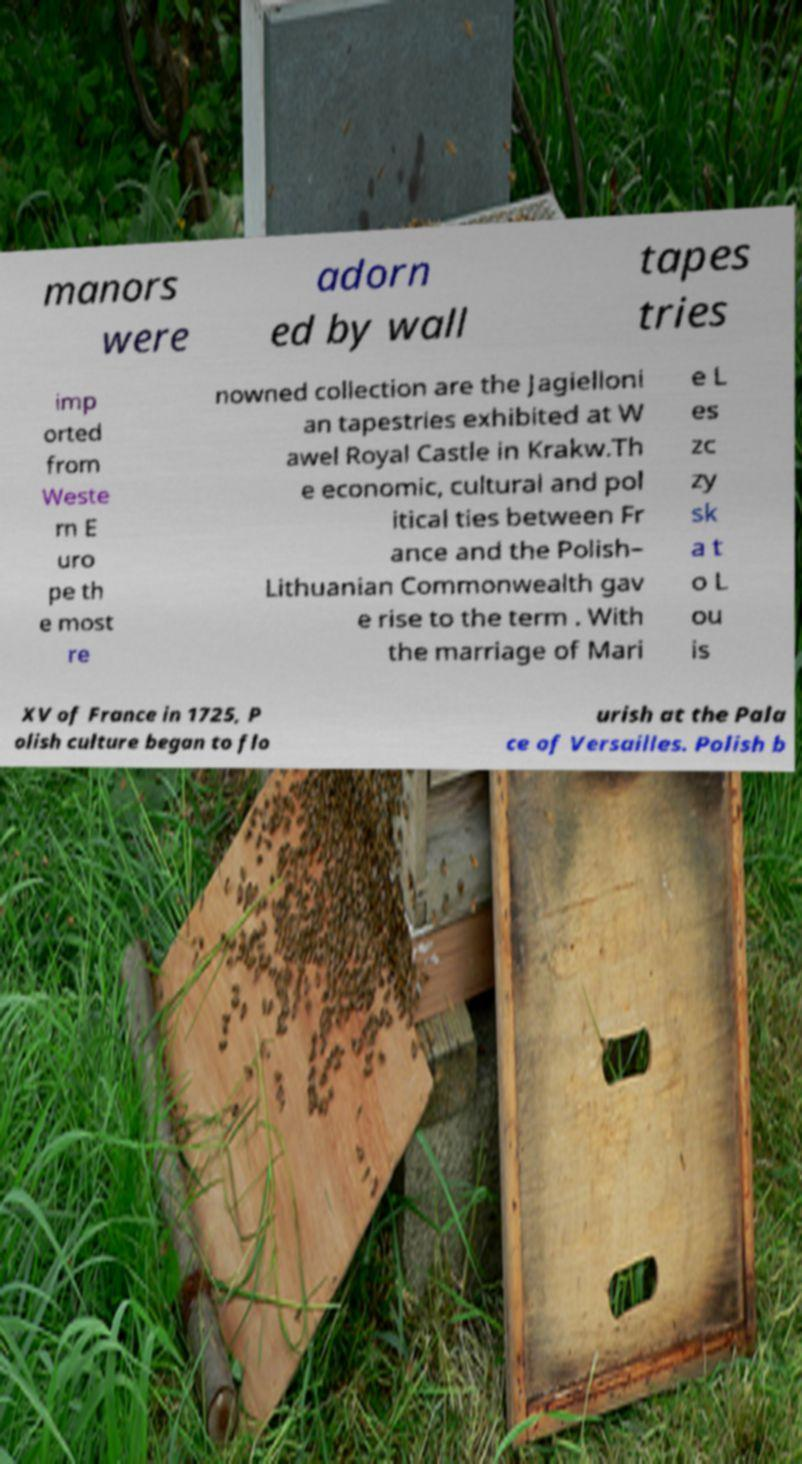Can you read and provide the text displayed in the image?This photo seems to have some interesting text. Can you extract and type it out for me? manors were adorn ed by wall tapes tries imp orted from Weste rn E uro pe th e most re nowned collection are the Jagielloni an tapestries exhibited at W awel Royal Castle in Krakw.Th e economic, cultural and pol itical ties between Fr ance and the Polish– Lithuanian Commonwealth gav e rise to the term . With the marriage of Mari e L es zc zy sk a t o L ou is XV of France in 1725, P olish culture began to flo urish at the Pala ce of Versailles. Polish b 